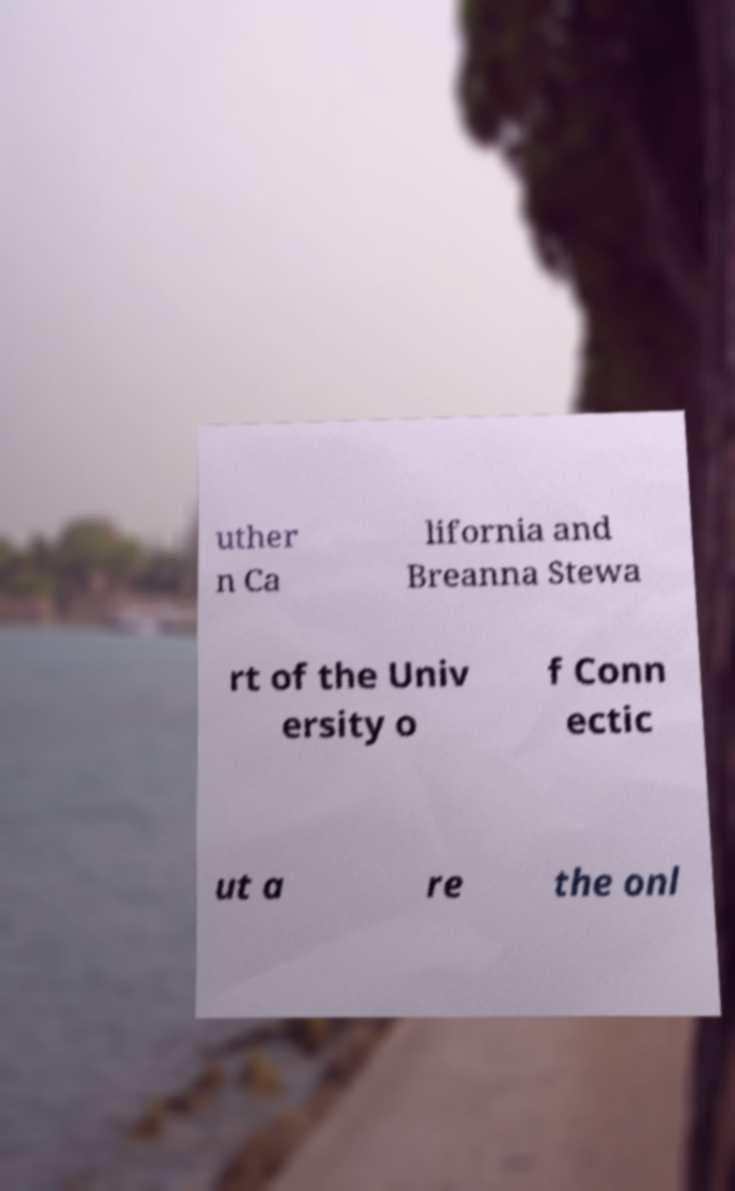Could you assist in decoding the text presented in this image and type it out clearly? uther n Ca lifornia and Breanna Stewa rt of the Univ ersity o f Conn ectic ut a re the onl 